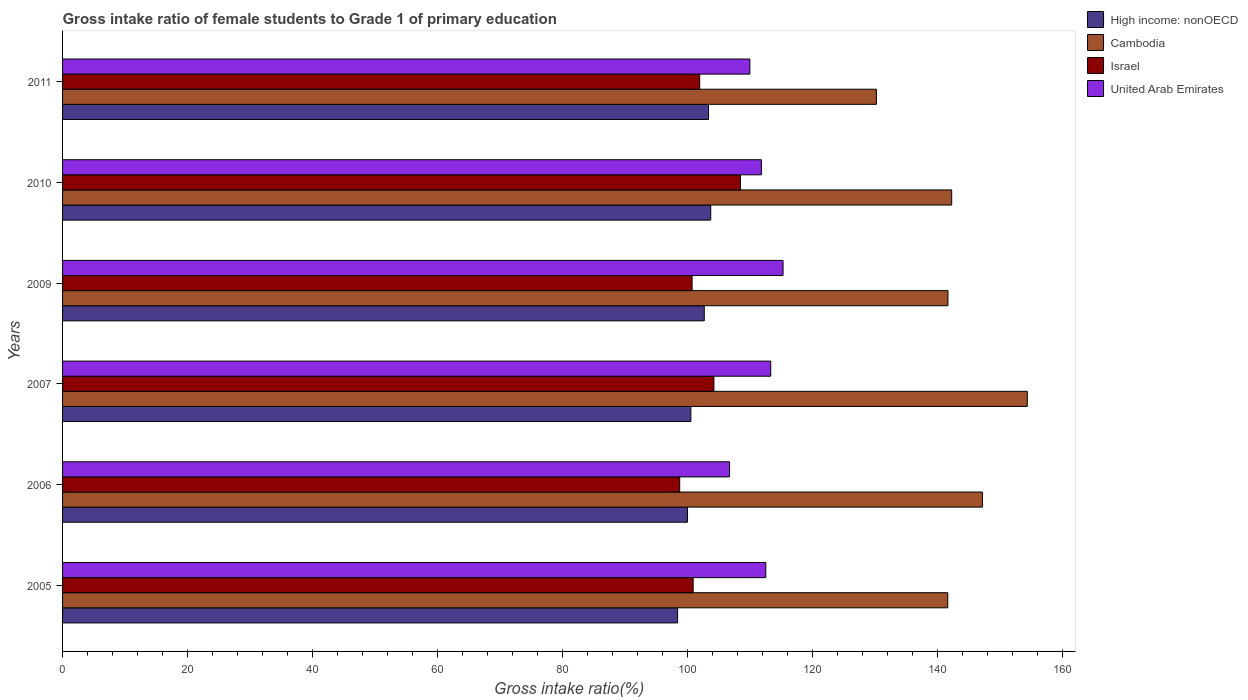Are the number of bars per tick equal to the number of legend labels?
Offer a very short reply. Yes. How many bars are there on the 5th tick from the top?
Your answer should be very brief. 4. How many bars are there on the 2nd tick from the bottom?
Your answer should be compact. 4. What is the label of the 1st group of bars from the top?
Offer a terse response. 2011. What is the gross intake ratio in United Arab Emirates in 2006?
Your response must be concise. 106.72. Across all years, what is the maximum gross intake ratio in Israel?
Give a very brief answer. 108.47. Across all years, what is the minimum gross intake ratio in High income: nonOECD?
Give a very brief answer. 98.41. What is the total gross intake ratio in United Arab Emirates in the graph?
Provide a succinct answer. 669.58. What is the difference between the gross intake ratio in United Arab Emirates in 2006 and that in 2007?
Ensure brevity in your answer.  -6.59. What is the difference between the gross intake ratio in United Arab Emirates in 2010 and the gross intake ratio in Cambodia in 2009?
Ensure brevity in your answer.  -29.85. What is the average gross intake ratio in United Arab Emirates per year?
Keep it short and to the point. 111.6. In the year 2006, what is the difference between the gross intake ratio in United Arab Emirates and gross intake ratio in High income: nonOECD?
Your answer should be very brief. 6.73. In how many years, is the gross intake ratio in Israel greater than 128 %?
Offer a very short reply. 0. What is the ratio of the gross intake ratio in High income: nonOECD in 2006 to that in 2009?
Give a very brief answer. 0.97. Is the difference between the gross intake ratio in United Arab Emirates in 2005 and 2009 greater than the difference between the gross intake ratio in High income: nonOECD in 2005 and 2009?
Give a very brief answer. Yes. What is the difference between the highest and the second highest gross intake ratio in Israel?
Your answer should be very brief. 4.25. What is the difference between the highest and the lowest gross intake ratio in High income: nonOECD?
Provide a short and direct response. 5.3. In how many years, is the gross intake ratio in United Arab Emirates greater than the average gross intake ratio in United Arab Emirates taken over all years?
Keep it short and to the point. 4. What does the 1st bar from the top in 2006 represents?
Keep it short and to the point. United Arab Emirates. What does the 4th bar from the bottom in 2011 represents?
Your response must be concise. United Arab Emirates. How many bars are there?
Offer a terse response. 24. Are all the bars in the graph horizontal?
Make the answer very short. Yes. How many years are there in the graph?
Ensure brevity in your answer.  6. What is the difference between two consecutive major ticks on the X-axis?
Make the answer very short. 20. Are the values on the major ticks of X-axis written in scientific E-notation?
Your response must be concise. No. Does the graph contain any zero values?
Ensure brevity in your answer.  No. Where does the legend appear in the graph?
Make the answer very short. Top right. How many legend labels are there?
Your answer should be compact. 4. What is the title of the graph?
Give a very brief answer. Gross intake ratio of female students to Grade 1 of primary education. Does "Kosovo" appear as one of the legend labels in the graph?
Provide a succinct answer. No. What is the label or title of the X-axis?
Keep it short and to the point. Gross intake ratio(%). What is the Gross intake ratio(%) in High income: nonOECD in 2005?
Keep it short and to the point. 98.41. What is the Gross intake ratio(%) of Cambodia in 2005?
Keep it short and to the point. 141.63. What is the Gross intake ratio(%) in Israel in 2005?
Your response must be concise. 100.89. What is the Gross intake ratio(%) of United Arab Emirates in 2005?
Offer a terse response. 112.51. What is the Gross intake ratio(%) in High income: nonOECD in 2006?
Provide a short and direct response. 99.99. What is the Gross intake ratio(%) of Cambodia in 2006?
Ensure brevity in your answer.  147.17. What is the Gross intake ratio(%) in Israel in 2006?
Provide a succinct answer. 98.74. What is the Gross intake ratio(%) in United Arab Emirates in 2006?
Offer a very short reply. 106.72. What is the Gross intake ratio(%) of High income: nonOECD in 2007?
Provide a succinct answer. 100.53. What is the Gross intake ratio(%) in Cambodia in 2007?
Offer a very short reply. 154.36. What is the Gross intake ratio(%) in Israel in 2007?
Your response must be concise. 104.22. What is the Gross intake ratio(%) in United Arab Emirates in 2007?
Provide a succinct answer. 113.3. What is the Gross intake ratio(%) of High income: nonOECD in 2009?
Your response must be concise. 102.67. What is the Gross intake ratio(%) in Cambodia in 2009?
Provide a short and direct response. 141.66. What is the Gross intake ratio(%) of Israel in 2009?
Your answer should be compact. 100.72. What is the Gross intake ratio(%) in United Arab Emirates in 2009?
Ensure brevity in your answer.  115.28. What is the Gross intake ratio(%) of High income: nonOECD in 2010?
Provide a short and direct response. 103.7. What is the Gross intake ratio(%) in Cambodia in 2010?
Provide a succinct answer. 142.26. What is the Gross intake ratio(%) in Israel in 2010?
Keep it short and to the point. 108.47. What is the Gross intake ratio(%) in United Arab Emirates in 2010?
Ensure brevity in your answer.  111.81. What is the Gross intake ratio(%) in High income: nonOECD in 2011?
Provide a succinct answer. 103.35. What is the Gross intake ratio(%) in Cambodia in 2011?
Make the answer very short. 130.21. What is the Gross intake ratio(%) in Israel in 2011?
Your answer should be compact. 101.94. What is the Gross intake ratio(%) in United Arab Emirates in 2011?
Ensure brevity in your answer.  109.96. Across all years, what is the maximum Gross intake ratio(%) of High income: nonOECD?
Provide a succinct answer. 103.7. Across all years, what is the maximum Gross intake ratio(%) of Cambodia?
Ensure brevity in your answer.  154.36. Across all years, what is the maximum Gross intake ratio(%) in Israel?
Keep it short and to the point. 108.47. Across all years, what is the maximum Gross intake ratio(%) of United Arab Emirates?
Make the answer very short. 115.28. Across all years, what is the minimum Gross intake ratio(%) in High income: nonOECD?
Make the answer very short. 98.41. Across all years, what is the minimum Gross intake ratio(%) in Cambodia?
Ensure brevity in your answer.  130.21. Across all years, what is the minimum Gross intake ratio(%) of Israel?
Keep it short and to the point. 98.74. Across all years, what is the minimum Gross intake ratio(%) in United Arab Emirates?
Keep it short and to the point. 106.72. What is the total Gross intake ratio(%) of High income: nonOECD in the graph?
Keep it short and to the point. 608.65. What is the total Gross intake ratio(%) in Cambodia in the graph?
Provide a succinct answer. 857.29. What is the total Gross intake ratio(%) in Israel in the graph?
Offer a very short reply. 614.97. What is the total Gross intake ratio(%) in United Arab Emirates in the graph?
Provide a succinct answer. 669.58. What is the difference between the Gross intake ratio(%) in High income: nonOECD in 2005 and that in 2006?
Your response must be concise. -1.58. What is the difference between the Gross intake ratio(%) of Cambodia in 2005 and that in 2006?
Keep it short and to the point. -5.54. What is the difference between the Gross intake ratio(%) of Israel in 2005 and that in 2006?
Make the answer very short. 2.15. What is the difference between the Gross intake ratio(%) in United Arab Emirates in 2005 and that in 2006?
Provide a succinct answer. 5.8. What is the difference between the Gross intake ratio(%) of High income: nonOECD in 2005 and that in 2007?
Provide a short and direct response. -2.12. What is the difference between the Gross intake ratio(%) of Cambodia in 2005 and that in 2007?
Your answer should be compact. -12.72. What is the difference between the Gross intake ratio(%) in Israel in 2005 and that in 2007?
Ensure brevity in your answer.  -3.32. What is the difference between the Gross intake ratio(%) of United Arab Emirates in 2005 and that in 2007?
Provide a succinct answer. -0.79. What is the difference between the Gross intake ratio(%) of High income: nonOECD in 2005 and that in 2009?
Ensure brevity in your answer.  -4.26. What is the difference between the Gross intake ratio(%) in Cambodia in 2005 and that in 2009?
Ensure brevity in your answer.  -0.03. What is the difference between the Gross intake ratio(%) in Israel in 2005 and that in 2009?
Offer a terse response. 0.17. What is the difference between the Gross intake ratio(%) in United Arab Emirates in 2005 and that in 2009?
Give a very brief answer. -2.76. What is the difference between the Gross intake ratio(%) in High income: nonOECD in 2005 and that in 2010?
Ensure brevity in your answer.  -5.3. What is the difference between the Gross intake ratio(%) of Cambodia in 2005 and that in 2010?
Make the answer very short. -0.63. What is the difference between the Gross intake ratio(%) in Israel in 2005 and that in 2010?
Make the answer very short. -7.57. What is the difference between the Gross intake ratio(%) of United Arab Emirates in 2005 and that in 2010?
Your response must be concise. 0.71. What is the difference between the Gross intake ratio(%) in High income: nonOECD in 2005 and that in 2011?
Offer a very short reply. -4.94. What is the difference between the Gross intake ratio(%) of Cambodia in 2005 and that in 2011?
Your answer should be compact. 11.42. What is the difference between the Gross intake ratio(%) in Israel in 2005 and that in 2011?
Offer a very short reply. -1.05. What is the difference between the Gross intake ratio(%) in United Arab Emirates in 2005 and that in 2011?
Make the answer very short. 2.55. What is the difference between the Gross intake ratio(%) of High income: nonOECD in 2006 and that in 2007?
Offer a terse response. -0.54. What is the difference between the Gross intake ratio(%) in Cambodia in 2006 and that in 2007?
Your answer should be very brief. -7.18. What is the difference between the Gross intake ratio(%) in Israel in 2006 and that in 2007?
Your answer should be compact. -5.48. What is the difference between the Gross intake ratio(%) of United Arab Emirates in 2006 and that in 2007?
Provide a succinct answer. -6.59. What is the difference between the Gross intake ratio(%) in High income: nonOECD in 2006 and that in 2009?
Keep it short and to the point. -2.68. What is the difference between the Gross intake ratio(%) in Cambodia in 2006 and that in 2009?
Give a very brief answer. 5.51. What is the difference between the Gross intake ratio(%) in Israel in 2006 and that in 2009?
Provide a short and direct response. -1.98. What is the difference between the Gross intake ratio(%) of United Arab Emirates in 2006 and that in 2009?
Make the answer very short. -8.56. What is the difference between the Gross intake ratio(%) in High income: nonOECD in 2006 and that in 2010?
Provide a succinct answer. -3.71. What is the difference between the Gross intake ratio(%) of Cambodia in 2006 and that in 2010?
Make the answer very short. 4.91. What is the difference between the Gross intake ratio(%) of Israel in 2006 and that in 2010?
Your answer should be compact. -9.73. What is the difference between the Gross intake ratio(%) in United Arab Emirates in 2006 and that in 2010?
Offer a terse response. -5.09. What is the difference between the Gross intake ratio(%) in High income: nonOECD in 2006 and that in 2011?
Your response must be concise. -3.36. What is the difference between the Gross intake ratio(%) in Cambodia in 2006 and that in 2011?
Give a very brief answer. 16.96. What is the difference between the Gross intake ratio(%) in Israel in 2006 and that in 2011?
Provide a short and direct response. -3.2. What is the difference between the Gross intake ratio(%) of United Arab Emirates in 2006 and that in 2011?
Ensure brevity in your answer.  -3.25. What is the difference between the Gross intake ratio(%) in High income: nonOECD in 2007 and that in 2009?
Give a very brief answer. -2.14. What is the difference between the Gross intake ratio(%) in Cambodia in 2007 and that in 2009?
Your answer should be compact. 12.7. What is the difference between the Gross intake ratio(%) of Israel in 2007 and that in 2009?
Ensure brevity in your answer.  3.49. What is the difference between the Gross intake ratio(%) in United Arab Emirates in 2007 and that in 2009?
Keep it short and to the point. -1.97. What is the difference between the Gross intake ratio(%) of High income: nonOECD in 2007 and that in 2010?
Offer a terse response. -3.18. What is the difference between the Gross intake ratio(%) in Cambodia in 2007 and that in 2010?
Provide a short and direct response. 12.1. What is the difference between the Gross intake ratio(%) of Israel in 2007 and that in 2010?
Your answer should be compact. -4.25. What is the difference between the Gross intake ratio(%) in United Arab Emirates in 2007 and that in 2010?
Offer a very short reply. 1.49. What is the difference between the Gross intake ratio(%) of High income: nonOECD in 2007 and that in 2011?
Ensure brevity in your answer.  -2.83. What is the difference between the Gross intake ratio(%) of Cambodia in 2007 and that in 2011?
Give a very brief answer. 24.14. What is the difference between the Gross intake ratio(%) of Israel in 2007 and that in 2011?
Offer a very short reply. 2.28. What is the difference between the Gross intake ratio(%) of United Arab Emirates in 2007 and that in 2011?
Make the answer very short. 3.34. What is the difference between the Gross intake ratio(%) of High income: nonOECD in 2009 and that in 2010?
Offer a terse response. -1.03. What is the difference between the Gross intake ratio(%) of Cambodia in 2009 and that in 2010?
Give a very brief answer. -0.6. What is the difference between the Gross intake ratio(%) of Israel in 2009 and that in 2010?
Provide a succinct answer. -7.74. What is the difference between the Gross intake ratio(%) in United Arab Emirates in 2009 and that in 2010?
Your response must be concise. 3.47. What is the difference between the Gross intake ratio(%) in High income: nonOECD in 2009 and that in 2011?
Provide a short and direct response. -0.68. What is the difference between the Gross intake ratio(%) in Cambodia in 2009 and that in 2011?
Provide a short and direct response. 11.44. What is the difference between the Gross intake ratio(%) in Israel in 2009 and that in 2011?
Provide a succinct answer. -1.22. What is the difference between the Gross intake ratio(%) of United Arab Emirates in 2009 and that in 2011?
Give a very brief answer. 5.31. What is the difference between the Gross intake ratio(%) of High income: nonOECD in 2010 and that in 2011?
Your response must be concise. 0.35. What is the difference between the Gross intake ratio(%) in Cambodia in 2010 and that in 2011?
Provide a short and direct response. 12.04. What is the difference between the Gross intake ratio(%) of Israel in 2010 and that in 2011?
Offer a terse response. 6.53. What is the difference between the Gross intake ratio(%) of United Arab Emirates in 2010 and that in 2011?
Your answer should be very brief. 1.84. What is the difference between the Gross intake ratio(%) of High income: nonOECD in 2005 and the Gross intake ratio(%) of Cambodia in 2006?
Give a very brief answer. -48.77. What is the difference between the Gross intake ratio(%) in High income: nonOECD in 2005 and the Gross intake ratio(%) in Israel in 2006?
Your response must be concise. -0.33. What is the difference between the Gross intake ratio(%) in High income: nonOECD in 2005 and the Gross intake ratio(%) in United Arab Emirates in 2006?
Your response must be concise. -8.31. What is the difference between the Gross intake ratio(%) of Cambodia in 2005 and the Gross intake ratio(%) of Israel in 2006?
Your answer should be very brief. 42.89. What is the difference between the Gross intake ratio(%) in Cambodia in 2005 and the Gross intake ratio(%) in United Arab Emirates in 2006?
Your response must be concise. 34.91. What is the difference between the Gross intake ratio(%) in Israel in 2005 and the Gross intake ratio(%) in United Arab Emirates in 2006?
Make the answer very short. -5.82. What is the difference between the Gross intake ratio(%) in High income: nonOECD in 2005 and the Gross intake ratio(%) in Cambodia in 2007?
Offer a very short reply. -55.95. What is the difference between the Gross intake ratio(%) of High income: nonOECD in 2005 and the Gross intake ratio(%) of Israel in 2007?
Provide a short and direct response. -5.81. What is the difference between the Gross intake ratio(%) of High income: nonOECD in 2005 and the Gross intake ratio(%) of United Arab Emirates in 2007?
Provide a short and direct response. -14.9. What is the difference between the Gross intake ratio(%) in Cambodia in 2005 and the Gross intake ratio(%) in Israel in 2007?
Provide a short and direct response. 37.42. What is the difference between the Gross intake ratio(%) of Cambodia in 2005 and the Gross intake ratio(%) of United Arab Emirates in 2007?
Provide a short and direct response. 28.33. What is the difference between the Gross intake ratio(%) in Israel in 2005 and the Gross intake ratio(%) in United Arab Emirates in 2007?
Offer a terse response. -12.41. What is the difference between the Gross intake ratio(%) of High income: nonOECD in 2005 and the Gross intake ratio(%) of Cambodia in 2009?
Provide a short and direct response. -43.25. What is the difference between the Gross intake ratio(%) of High income: nonOECD in 2005 and the Gross intake ratio(%) of Israel in 2009?
Offer a very short reply. -2.32. What is the difference between the Gross intake ratio(%) in High income: nonOECD in 2005 and the Gross intake ratio(%) in United Arab Emirates in 2009?
Ensure brevity in your answer.  -16.87. What is the difference between the Gross intake ratio(%) of Cambodia in 2005 and the Gross intake ratio(%) of Israel in 2009?
Keep it short and to the point. 40.91. What is the difference between the Gross intake ratio(%) of Cambodia in 2005 and the Gross intake ratio(%) of United Arab Emirates in 2009?
Your answer should be very brief. 26.35. What is the difference between the Gross intake ratio(%) in Israel in 2005 and the Gross intake ratio(%) in United Arab Emirates in 2009?
Your response must be concise. -14.38. What is the difference between the Gross intake ratio(%) in High income: nonOECD in 2005 and the Gross intake ratio(%) in Cambodia in 2010?
Provide a succinct answer. -43.85. What is the difference between the Gross intake ratio(%) of High income: nonOECD in 2005 and the Gross intake ratio(%) of Israel in 2010?
Offer a very short reply. -10.06. What is the difference between the Gross intake ratio(%) of High income: nonOECD in 2005 and the Gross intake ratio(%) of United Arab Emirates in 2010?
Provide a short and direct response. -13.4. What is the difference between the Gross intake ratio(%) of Cambodia in 2005 and the Gross intake ratio(%) of Israel in 2010?
Provide a short and direct response. 33.17. What is the difference between the Gross intake ratio(%) in Cambodia in 2005 and the Gross intake ratio(%) in United Arab Emirates in 2010?
Provide a succinct answer. 29.82. What is the difference between the Gross intake ratio(%) of Israel in 2005 and the Gross intake ratio(%) of United Arab Emirates in 2010?
Make the answer very short. -10.91. What is the difference between the Gross intake ratio(%) of High income: nonOECD in 2005 and the Gross intake ratio(%) of Cambodia in 2011?
Offer a terse response. -31.81. What is the difference between the Gross intake ratio(%) in High income: nonOECD in 2005 and the Gross intake ratio(%) in Israel in 2011?
Your response must be concise. -3.53. What is the difference between the Gross intake ratio(%) in High income: nonOECD in 2005 and the Gross intake ratio(%) in United Arab Emirates in 2011?
Your answer should be very brief. -11.56. What is the difference between the Gross intake ratio(%) in Cambodia in 2005 and the Gross intake ratio(%) in Israel in 2011?
Offer a very short reply. 39.69. What is the difference between the Gross intake ratio(%) of Cambodia in 2005 and the Gross intake ratio(%) of United Arab Emirates in 2011?
Provide a succinct answer. 31.67. What is the difference between the Gross intake ratio(%) of Israel in 2005 and the Gross intake ratio(%) of United Arab Emirates in 2011?
Offer a terse response. -9.07. What is the difference between the Gross intake ratio(%) in High income: nonOECD in 2006 and the Gross intake ratio(%) in Cambodia in 2007?
Keep it short and to the point. -54.37. What is the difference between the Gross intake ratio(%) of High income: nonOECD in 2006 and the Gross intake ratio(%) of Israel in 2007?
Make the answer very short. -4.23. What is the difference between the Gross intake ratio(%) of High income: nonOECD in 2006 and the Gross intake ratio(%) of United Arab Emirates in 2007?
Your response must be concise. -13.31. What is the difference between the Gross intake ratio(%) in Cambodia in 2006 and the Gross intake ratio(%) in Israel in 2007?
Give a very brief answer. 42.96. What is the difference between the Gross intake ratio(%) of Cambodia in 2006 and the Gross intake ratio(%) of United Arab Emirates in 2007?
Make the answer very short. 33.87. What is the difference between the Gross intake ratio(%) in Israel in 2006 and the Gross intake ratio(%) in United Arab Emirates in 2007?
Your answer should be very brief. -14.56. What is the difference between the Gross intake ratio(%) in High income: nonOECD in 2006 and the Gross intake ratio(%) in Cambodia in 2009?
Offer a very short reply. -41.67. What is the difference between the Gross intake ratio(%) in High income: nonOECD in 2006 and the Gross intake ratio(%) in Israel in 2009?
Provide a succinct answer. -0.73. What is the difference between the Gross intake ratio(%) in High income: nonOECD in 2006 and the Gross intake ratio(%) in United Arab Emirates in 2009?
Offer a very short reply. -15.29. What is the difference between the Gross intake ratio(%) of Cambodia in 2006 and the Gross intake ratio(%) of Israel in 2009?
Give a very brief answer. 46.45. What is the difference between the Gross intake ratio(%) in Cambodia in 2006 and the Gross intake ratio(%) in United Arab Emirates in 2009?
Provide a succinct answer. 31.89. What is the difference between the Gross intake ratio(%) in Israel in 2006 and the Gross intake ratio(%) in United Arab Emirates in 2009?
Give a very brief answer. -16.54. What is the difference between the Gross intake ratio(%) of High income: nonOECD in 2006 and the Gross intake ratio(%) of Cambodia in 2010?
Your response must be concise. -42.27. What is the difference between the Gross intake ratio(%) in High income: nonOECD in 2006 and the Gross intake ratio(%) in Israel in 2010?
Keep it short and to the point. -8.48. What is the difference between the Gross intake ratio(%) in High income: nonOECD in 2006 and the Gross intake ratio(%) in United Arab Emirates in 2010?
Keep it short and to the point. -11.82. What is the difference between the Gross intake ratio(%) in Cambodia in 2006 and the Gross intake ratio(%) in Israel in 2010?
Your answer should be compact. 38.71. What is the difference between the Gross intake ratio(%) in Cambodia in 2006 and the Gross intake ratio(%) in United Arab Emirates in 2010?
Your response must be concise. 35.36. What is the difference between the Gross intake ratio(%) in Israel in 2006 and the Gross intake ratio(%) in United Arab Emirates in 2010?
Make the answer very short. -13.07. What is the difference between the Gross intake ratio(%) of High income: nonOECD in 2006 and the Gross intake ratio(%) of Cambodia in 2011?
Ensure brevity in your answer.  -30.23. What is the difference between the Gross intake ratio(%) of High income: nonOECD in 2006 and the Gross intake ratio(%) of Israel in 2011?
Your answer should be very brief. -1.95. What is the difference between the Gross intake ratio(%) of High income: nonOECD in 2006 and the Gross intake ratio(%) of United Arab Emirates in 2011?
Ensure brevity in your answer.  -9.97. What is the difference between the Gross intake ratio(%) in Cambodia in 2006 and the Gross intake ratio(%) in Israel in 2011?
Keep it short and to the point. 45.23. What is the difference between the Gross intake ratio(%) of Cambodia in 2006 and the Gross intake ratio(%) of United Arab Emirates in 2011?
Provide a short and direct response. 37.21. What is the difference between the Gross intake ratio(%) in Israel in 2006 and the Gross intake ratio(%) in United Arab Emirates in 2011?
Offer a very short reply. -11.23. What is the difference between the Gross intake ratio(%) in High income: nonOECD in 2007 and the Gross intake ratio(%) in Cambodia in 2009?
Provide a short and direct response. -41.13. What is the difference between the Gross intake ratio(%) in High income: nonOECD in 2007 and the Gross intake ratio(%) in Israel in 2009?
Offer a very short reply. -0.2. What is the difference between the Gross intake ratio(%) of High income: nonOECD in 2007 and the Gross intake ratio(%) of United Arab Emirates in 2009?
Your response must be concise. -14.75. What is the difference between the Gross intake ratio(%) in Cambodia in 2007 and the Gross intake ratio(%) in Israel in 2009?
Your response must be concise. 53.63. What is the difference between the Gross intake ratio(%) in Cambodia in 2007 and the Gross intake ratio(%) in United Arab Emirates in 2009?
Provide a short and direct response. 39.08. What is the difference between the Gross intake ratio(%) in Israel in 2007 and the Gross intake ratio(%) in United Arab Emirates in 2009?
Make the answer very short. -11.06. What is the difference between the Gross intake ratio(%) in High income: nonOECD in 2007 and the Gross intake ratio(%) in Cambodia in 2010?
Provide a short and direct response. -41.73. What is the difference between the Gross intake ratio(%) in High income: nonOECD in 2007 and the Gross intake ratio(%) in Israel in 2010?
Keep it short and to the point. -7.94. What is the difference between the Gross intake ratio(%) in High income: nonOECD in 2007 and the Gross intake ratio(%) in United Arab Emirates in 2010?
Provide a short and direct response. -11.28. What is the difference between the Gross intake ratio(%) in Cambodia in 2007 and the Gross intake ratio(%) in Israel in 2010?
Make the answer very short. 45.89. What is the difference between the Gross intake ratio(%) in Cambodia in 2007 and the Gross intake ratio(%) in United Arab Emirates in 2010?
Ensure brevity in your answer.  42.55. What is the difference between the Gross intake ratio(%) in Israel in 2007 and the Gross intake ratio(%) in United Arab Emirates in 2010?
Ensure brevity in your answer.  -7.59. What is the difference between the Gross intake ratio(%) in High income: nonOECD in 2007 and the Gross intake ratio(%) in Cambodia in 2011?
Your answer should be very brief. -29.69. What is the difference between the Gross intake ratio(%) of High income: nonOECD in 2007 and the Gross intake ratio(%) of Israel in 2011?
Keep it short and to the point. -1.41. What is the difference between the Gross intake ratio(%) in High income: nonOECD in 2007 and the Gross intake ratio(%) in United Arab Emirates in 2011?
Your response must be concise. -9.44. What is the difference between the Gross intake ratio(%) in Cambodia in 2007 and the Gross intake ratio(%) in Israel in 2011?
Offer a terse response. 52.42. What is the difference between the Gross intake ratio(%) of Cambodia in 2007 and the Gross intake ratio(%) of United Arab Emirates in 2011?
Your answer should be very brief. 44.39. What is the difference between the Gross intake ratio(%) in Israel in 2007 and the Gross intake ratio(%) in United Arab Emirates in 2011?
Keep it short and to the point. -5.75. What is the difference between the Gross intake ratio(%) in High income: nonOECD in 2009 and the Gross intake ratio(%) in Cambodia in 2010?
Offer a very short reply. -39.59. What is the difference between the Gross intake ratio(%) of High income: nonOECD in 2009 and the Gross intake ratio(%) of Israel in 2010?
Offer a terse response. -5.79. What is the difference between the Gross intake ratio(%) in High income: nonOECD in 2009 and the Gross intake ratio(%) in United Arab Emirates in 2010?
Your answer should be very brief. -9.14. What is the difference between the Gross intake ratio(%) in Cambodia in 2009 and the Gross intake ratio(%) in Israel in 2010?
Provide a succinct answer. 33.19. What is the difference between the Gross intake ratio(%) of Cambodia in 2009 and the Gross intake ratio(%) of United Arab Emirates in 2010?
Give a very brief answer. 29.85. What is the difference between the Gross intake ratio(%) in Israel in 2009 and the Gross intake ratio(%) in United Arab Emirates in 2010?
Give a very brief answer. -11.09. What is the difference between the Gross intake ratio(%) in High income: nonOECD in 2009 and the Gross intake ratio(%) in Cambodia in 2011?
Provide a short and direct response. -27.54. What is the difference between the Gross intake ratio(%) of High income: nonOECD in 2009 and the Gross intake ratio(%) of Israel in 2011?
Ensure brevity in your answer.  0.73. What is the difference between the Gross intake ratio(%) in High income: nonOECD in 2009 and the Gross intake ratio(%) in United Arab Emirates in 2011?
Give a very brief answer. -7.29. What is the difference between the Gross intake ratio(%) in Cambodia in 2009 and the Gross intake ratio(%) in Israel in 2011?
Offer a terse response. 39.72. What is the difference between the Gross intake ratio(%) in Cambodia in 2009 and the Gross intake ratio(%) in United Arab Emirates in 2011?
Your answer should be very brief. 31.69. What is the difference between the Gross intake ratio(%) in Israel in 2009 and the Gross intake ratio(%) in United Arab Emirates in 2011?
Your answer should be very brief. -9.24. What is the difference between the Gross intake ratio(%) in High income: nonOECD in 2010 and the Gross intake ratio(%) in Cambodia in 2011?
Your answer should be compact. -26.51. What is the difference between the Gross intake ratio(%) in High income: nonOECD in 2010 and the Gross intake ratio(%) in Israel in 2011?
Your answer should be very brief. 1.77. What is the difference between the Gross intake ratio(%) of High income: nonOECD in 2010 and the Gross intake ratio(%) of United Arab Emirates in 2011?
Make the answer very short. -6.26. What is the difference between the Gross intake ratio(%) in Cambodia in 2010 and the Gross intake ratio(%) in Israel in 2011?
Provide a short and direct response. 40.32. What is the difference between the Gross intake ratio(%) of Cambodia in 2010 and the Gross intake ratio(%) of United Arab Emirates in 2011?
Offer a terse response. 32.29. What is the difference between the Gross intake ratio(%) in Israel in 2010 and the Gross intake ratio(%) in United Arab Emirates in 2011?
Provide a succinct answer. -1.5. What is the average Gross intake ratio(%) of High income: nonOECD per year?
Offer a very short reply. 101.44. What is the average Gross intake ratio(%) in Cambodia per year?
Give a very brief answer. 142.88. What is the average Gross intake ratio(%) of Israel per year?
Your answer should be very brief. 102.5. What is the average Gross intake ratio(%) in United Arab Emirates per year?
Provide a succinct answer. 111.6. In the year 2005, what is the difference between the Gross intake ratio(%) of High income: nonOECD and Gross intake ratio(%) of Cambodia?
Provide a succinct answer. -43.22. In the year 2005, what is the difference between the Gross intake ratio(%) of High income: nonOECD and Gross intake ratio(%) of Israel?
Offer a terse response. -2.49. In the year 2005, what is the difference between the Gross intake ratio(%) of High income: nonOECD and Gross intake ratio(%) of United Arab Emirates?
Offer a terse response. -14.11. In the year 2005, what is the difference between the Gross intake ratio(%) in Cambodia and Gross intake ratio(%) in Israel?
Give a very brief answer. 40.74. In the year 2005, what is the difference between the Gross intake ratio(%) in Cambodia and Gross intake ratio(%) in United Arab Emirates?
Provide a succinct answer. 29.12. In the year 2005, what is the difference between the Gross intake ratio(%) in Israel and Gross intake ratio(%) in United Arab Emirates?
Provide a short and direct response. -11.62. In the year 2006, what is the difference between the Gross intake ratio(%) of High income: nonOECD and Gross intake ratio(%) of Cambodia?
Your response must be concise. -47.18. In the year 2006, what is the difference between the Gross intake ratio(%) of High income: nonOECD and Gross intake ratio(%) of Israel?
Offer a terse response. 1.25. In the year 2006, what is the difference between the Gross intake ratio(%) of High income: nonOECD and Gross intake ratio(%) of United Arab Emirates?
Your answer should be very brief. -6.73. In the year 2006, what is the difference between the Gross intake ratio(%) in Cambodia and Gross intake ratio(%) in Israel?
Make the answer very short. 48.43. In the year 2006, what is the difference between the Gross intake ratio(%) in Cambodia and Gross intake ratio(%) in United Arab Emirates?
Offer a very short reply. 40.46. In the year 2006, what is the difference between the Gross intake ratio(%) in Israel and Gross intake ratio(%) in United Arab Emirates?
Your answer should be compact. -7.98. In the year 2007, what is the difference between the Gross intake ratio(%) in High income: nonOECD and Gross intake ratio(%) in Cambodia?
Give a very brief answer. -53.83. In the year 2007, what is the difference between the Gross intake ratio(%) of High income: nonOECD and Gross intake ratio(%) of Israel?
Provide a short and direct response. -3.69. In the year 2007, what is the difference between the Gross intake ratio(%) in High income: nonOECD and Gross intake ratio(%) in United Arab Emirates?
Offer a very short reply. -12.78. In the year 2007, what is the difference between the Gross intake ratio(%) in Cambodia and Gross intake ratio(%) in Israel?
Provide a succinct answer. 50.14. In the year 2007, what is the difference between the Gross intake ratio(%) in Cambodia and Gross intake ratio(%) in United Arab Emirates?
Your response must be concise. 41.05. In the year 2007, what is the difference between the Gross intake ratio(%) in Israel and Gross intake ratio(%) in United Arab Emirates?
Your answer should be very brief. -9.09. In the year 2009, what is the difference between the Gross intake ratio(%) in High income: nonOECD and Gross intake ratio(%) in Cambodia?
Your answer should be very brief. -38.99. In the year 2009, what is the difference between the Gross intake ratio(%) of High income: nonOECD and Gross intake ratio(%) of Israel?
Provide a succinct answer. 1.95. In the year 2009, what is the difference between the Gross intake ratio(%) of High income: nonOECD and Gross intake ratio(%) of United Arab Emirates?
Give a very brief answer. -12.61. In the year 2009, what is the difference between the Gross intake ratio(%) in Cambodia and Gross intake ratio(%) in Israel?
Offer a very short reply. 40.94. In the year 2009, what is the difference between the Gross intake ratio(%) in Cambodia and Gross intake ratio(%) in United Arab Emirates?
Your answer should be compact. 26.38. In the year 2009, what is the difference between the Gross intake ratio(%) in Israel and Gross intake ratio(%) in United Arab Emirates?
Ensure brevity in your answer.  -14.56. In the year 2010, what is the difference between the Gross intake ratio(%) in High income: nonOECD and Gross intake ratio(%) in Cambodia?
Give a very brief answer. -38.55. In the year 2010, what is the difference between the Gross intake ratio(%) in High income: nonOECD and Gross intake ratio(%) in Israel?
Ensure brevity in your answer.  -4.76. In the year 2010, what is the difference between the Gross intake ratio(%) in High income: nonOECD and Gross intake ratio(%) in United Arab Emirates?
Offer a terse response. -8.1. In the year 2010, what is the difference between the Gross intake ratio(%) of Cambodia and Gross intake ratio(%) of Israel?
Your response must be concise. 33.79. In the year 2010, what is the difference between the Gross intake ratio(%) in Cambodia and Gross intake ratio(%) in United Arab Emirates?
Your answer should be compact. 30.45. In the year 2010, what is the difference between the Gross intake ratio(%) in Israel and Gross intake ratio(%) in United Arab Emirates?
Your answer should be compact. -3.34. In the year 2011, what is the difference between the Gross intake ratio(%) of High income: nonOECD and Gross intake ratio(%) of Cambodia?
Give a very brief answer. -26.86. In the year 2011, what is the difference between the Gross intake ratio(%) of High income: nonOECD and Gross intake ratio(%) of Israel?
Your answer should be compact. 1.41. In the year 2011, what is the difference between the Gross intake ratio(%) in High income: nonOECD and Gross intake ratio(%) in United Arab Emirates?
Your answer should be compact. -6.61. In the year 2011, what is the difference between the Gross intake ratio(%) in Cambodia and Gross intake ratio(%) in Israel?
Provide a short and direct response. 28.28. In the year 2011, what is the difference between the Gross intake ratio(%) of Cambodia and Gross intake ratio(%) of United Arab Emirates?
Offer a very short reply. 20.25. In the year 2011, what is the difference between the Gross intake ratio(%) of Israel and Gross intake ratio(%) of United Arab Emirates?
Give a very brief answer. -8.03. What is the ratio of the Gross intake ratio(%) of High income: nonOECD in 2005 to that in 2006?
Your answer should be compact. 0.98. What is the ratio of the Gross intake ratio(%) in Cambodia in 2005 to that in 2006?
Ensure brevity in your answer.  0.96. What is the ratio of the Gross intake ratio(%) in Israel in 2005 to that in 2006?
Provide a short and direct response. 1.02. What is the ratio of the Gross intake ratio(%) of United Arab Emirates in 2005 to that in 2006?
Your answer should be compact. 1.05. What is the ratio of the Gross intake ratio(%) of High income: nonOECD in 2005 to that in 2007?
Make the answer very short. 0.98. What is the ratio of the Gross intake ratio(%) in Cambodia in 2005 to that in 2007?
Offer a very short reply. 0.92. What is the ratio of the Gross intake ratio(%) in Israel in 2005 to that in 2007?
Ensure brevity in your answer.  0.97. What is the ratio of the Gross intake ratio(%) in High income: nonOECD in 2005 to that in 2009?
Offer a terse response. 0.96. What is the ratio of the Gross intake ratio(%) in Cambodia in 2005 to that in 2009?
Your answer should be very brief. 1. What is the ratio of the Gross intake ratio(%) in Israel in 2005 to that in 2009?
Your response must be concise. 1. What is the ratio of the Gross intake ratio(%) in United Arab Emirates in 2005 to that in 2009?
Keep it short and to the point. 0.98. What is the ratio of the Gross intake ratio(%) of High income: nonOECD in 2005 to that in 2010?
Your response must be concise. 0.95. What is the ratio of the Gross intake ratio(%) of Israel in 2005 to that in 2010?
Keep it short and to the point. 0.93. What is the ratio of the Gross intake ratio(%) in High income: nonOECD in 2005 to that in 2011?
Your response must be concise. 0.95. What is the ratio of the Gross intake ratio(%) in Cambodia in 2005 to that in 2011?
Keep it short and to the point. 1.09. What is the ratio of the Gross intake ratio(%) in United Arab Emirates in 2005 to that in 2011?
Offer a very short reply. 1.02. What is the ratio of the Gross intake ratio(%) in Cambodia in 2006 to that in 2007?
Provide a short and direct response. 0.95. What is the ratio of the Gross intake ratio(%) of Israel in 2006 to that in 2007?
Give a very brief answer. 0.95. What is the ratio of the Gross intake ratio(%) in United Arab Emirates in 2006 to that in 2007?
Give a very brief answer. 0.94. What is the ratio of the Gross intake ratio(%) in High income: nonOECD in 2006 to that in 2009?
Provide a short and direct response. 0.97. What is the ratio of the Gross intake ratio(%) in Cambodia in 2006 to that in 2009?
Provide a short and direct response. 1.04. What is the ratio of the Gross intake ratio(%) of Israel in 2006 to that in 2009?
Make the answer very short. 0.98. What is the ratio of the Gross intake ratio(%) in United Arab Emirates in 2006 to that in 2009?
Keep it short and to the point. 0.93. What is the ratio of the Gross intake ratio(%) of High income: nonOECD in 2006 to that in 2010?
Provide a succinct answer. 0.96. What is the ratio of the Gross intake ratio(%) of Cambodia in 2006 to that in 2010?
Offer a very short reply. 1.03. What is the ratio of the Gross intake ratio(%) in Israel in 2006 to that in 2010?
Ensure brevity in your answer.  0.91. What is the ratio of the Gross intake ratio(%) in United Arab Emirates in 2006 to that in 2010?
Your response must be concise. 0.95. What is the ratio of the Gross intake ratio(%) in High income: nonOECD in 2006 to that in 2011?
Your answer should be compact. 0.97. What is the ratio of the Gross intake ratio(%) of Cambodia in 2006 to that in 2011?
Provide a short and direct response. 1.13. What is the ratio of the Gross intake ratio(%) in Israel in 2006 to that in 2011?
Offer a terse response. 0.97. What is the ratio of the Gross intake ratio(%) in United Arab Emirates in 2006 to that in 2011?
Your answer should be very brief. 0.97. What is the ratio of the Gross intake ratio(%) in High income: nonOECD in 2007 to that in 2009?
Provide a succinct answer. 0.98. What is the ratio of the Gross intake ratio(%) in Cambodia in 2007 to that in 2009?
Offer a very short reply. 1.09. What is the ratio of the Gross intake ratio(%) of Israel in 2007 to that in 2009?
Ensure brevity in your answer.  1.03. What is the ratio of the Gross intake ratio(%) in United Arab Emirates in 2007 to that in 2009?
Your answer should be compact. 0.98. What is the ratio of the Gross intake ratio(%) of High income: nonOECD in 2007 to that in 2010?
Your answer should be very brief. 0.97. What is the ratio of the Gross intake ratio(%) in Cambodia in 2007 to that in 2010?
Offer a terse response. 1.08. What is the ratio of the Gross intake ratio(%) of Israel in 2007 to that in 2010?
Keep it short and to the point. 0.96. What is the ratio of the Gross intake ratio(%) in United Arab Emirates in 2007 to that in 2010?
Your response must be concise. 1.01. What is the ratio of the Gross intake ratio(%) of High income: nonOECD in 2007 to that in 2011?
Your answer should be very brief. 0.97. What is the ratio of the Gross intake ratio(%) of Cambodia in 2007 to that in 2011?
Provide a short and direct response. 1.19. What is the ratio of the Gross intake ratio(%) of Israel in 2007 to that in 2011?
Your answer should be very brief. 1.02. What is the ratio of the Gross intake ratio(%) in United Arab Emirates in 2007 to that in 2011?
Keep it short and to the point. 1.03. What is the ratio of the Gross intake ratio(%) of High income: nonOECD in 2009 to that in 2010?
Ensure brevity in your answer.  0.99. What is the ratio of the Gross intake ratio(%) in Cambodia in 2009 to that in 2010?
Provide a succinct answer. 1. What is the ratio of the Gross intake ratio(%) of United Arab Emirates in 2009 to that in 2010?
Offer a very short reply. 1.03. What is the ratio of the Gross intake ratio(%) in Cambodia in 2009 to that in 2011?
Your answer should be compact. 1.09. What is the ratio of the Gross intake ratio(%) in United Arab Emirates in 2009 to that in 2011?
Ensure brevity in your answer.  1.05. What is the ratio of the Gross intake ratio(%) in High income: nonOECD in 2010 to that in 2011?
Provide a short and direct response. 1. What is the ratio of the Gross intake ratio(%) of Cambodia in 2010 to that in 2011?
Your answer should be very brief. 1.09. What is the ratio of the Gross intake ratio(%) in Israel in 2010 to that in 2011?
Provide a short and direct response. 1.06. What is the ratio of the Gross intake ratio(%) of United Arab Emirates in 2010 to that in 2011?
Offer a very short reply. 1.02. What is the difference between the highest and the second highest Gross intake ratio(%) of High income: nonOECD?
Ensure brevity in your answer.  0.35. What is the difference between the highest and the second highest Gross intake ratio(%) of Cambodia?
Provide a succinct answer. 7.18. What is the difference between the highest and the second highest Gross intake ratio(%) in Israel?
Keep it short and to the point. 4.25. What is the difference between the highest and the second highest Gross intake ratio(%) of United Arab Emirates?
Offer a very short reply. 1.97. What is the difference between the highest and the lowest Gross intake ratio(%) of High income: nonOECD?
Provide a short and direct response. 5.3. What is the difference between the highest and the lowest Gross intake ratio(%) in Cambodia?
Provide a short and direct response. 24.14. What is the difference between the highest and the lowest Gross intake ratio(%) in Israel?
Your answer should be very brief. 9.73. What is the difference between the highest and the lowest Gross intake ratio(%) in United Arab Emirates?
Your answer should be compact. 8.56. 